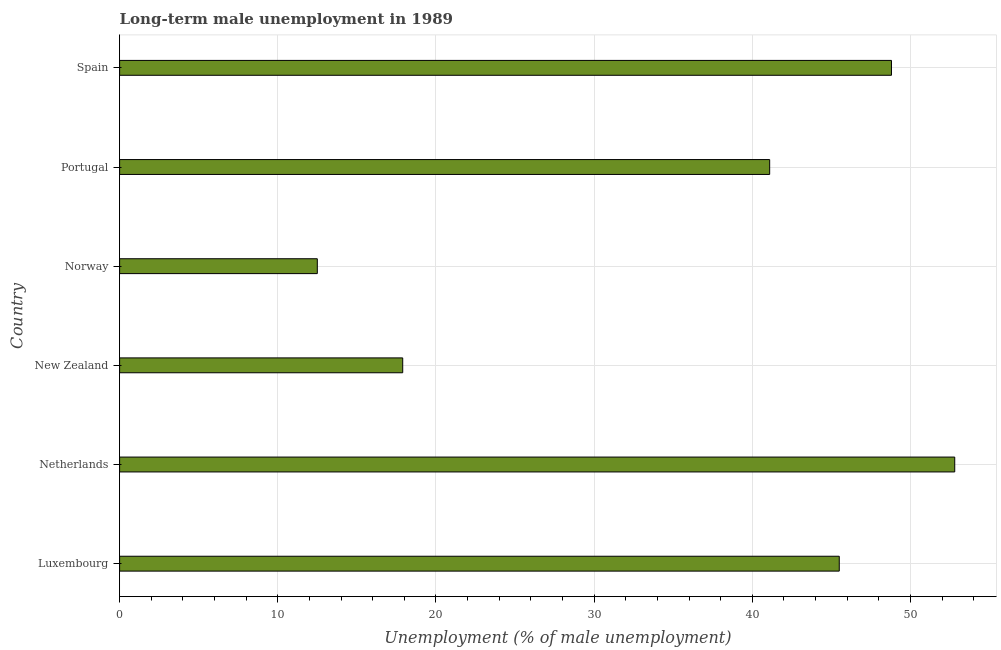Does the graph contain any zero values?
Provide a succinct answer. No. Does the graph contain grids?
Offer a terse response. Yes. What is the title of the graph?
Ensure brevity in your answer.  Long-term male unemployment in 1989. What is the label or title of the X-axis?
Offer a terse response. Unemployment (% of male unemployment). What is the long-term male unemployment in Norway?
Keep it short and to the point. 12.5. Across all countries, what is the maximum long-term male unemployment?
Your answer should be very brief. 52.8. Across all countries, what is the minimum long-term male unemployment?
Your response must be concise. 12.5. In which country was the long-term male unemployment minimum?
Your answer should be very brief. Norway. What is the sum of the long-term male unemployment?
Your answer should be very brief. 218.6. What is the difference between the long-term male unemployment in New Zealand and Portugal?
Your answer should be compact. -23.2. What is the average long-term male unemployment per country?
Your response must be concise. 36.43. What is the median long-term male unemployment?
Provide a short and direct response. 43.3. What is the ratio of the long-term male unemployment in Netherlands to that in Norway?
Your answer should be very brief. 4.22. What is the difference between the highest and the second highest long-term male unemployment?
Provide a short and direct response. 4. Is the sum of the long-term male unemployment in New Zealand and Norway greater than the maximum long-term male unemployment across all countries?
Your answer should be compact. No. What is the difference between the highest and the lowest long-term male unemployment?
Offer a terse response. 40.3. How many bars are there?
Offer a terse response. 6. How many countries are there in the graph?
Your answer should be compact. 6. Are the values on the major ticks of X-axis written in scientific E-notation?
Provide a short and direct response. No. What is the Unemployment (% of male unemployment) of Luxembourg?
Provide a succinct answer. 45.5. What is the Unemployment (% of male unemployment) in Netherlands?
Offer a very short reply. 52.8. What is the Unemployment (% of male unemployment) in New Zealand?
Keep it short and to the point. 17.9. What is the Unemployment (% of male unemployment) in Portugal?
Offer a very short reply. 41.1. What is the Unemployment (% of male unemployment) of Spain?
Offer a terse response. 48.8. What is the difference between the Unemployment (% of male unemployment) in Luxembourg and Netherlands?
Keep it short and to the point. -7.3. What is the difference between the Unemployment (% of male unemployment) in Luxembourg and New Zealand?
Offer a very short reply. 27.6. What is the difference between the Unemployment (% of male unemployment) in Luxembourg and Norway?
Your response must be concise. 33. What is the difference between the Unemployment (% of male unemployment) in Luxembourg and Portugal?
Keep it short and to the point. 4.4. What is the difference between the Unemployment (% of male unemployment) in Netherlands and New Zealand?
Ensure brevity in your answer.  34.9. What is the difference between the Unemployment (% of male unemployment) in Netherlands and Norway?
Offer a terse response. 40.3. What is the difference between the Unemployment (% of male unemployment) in Netherlands and Spain?
Provide a succinct answer. 4. What is the difference between the Unemployment (% of male unemployment) in New Zealand and Portugal?
Keep it short and to the point. -23.2. What is the difference between the Unemployment (% of male unemployment) in New Zealand and Spain?
Provide a succinct answer. -30.9. What is the difference between the Unemployment (% of male unemployment) in Norway and Portugal?
Your answer should be compact. -28.6. What is the difference between the Unemployment (% of male unemployment) in Norway and Spain?
Your answer should be very brief. -36.3. What is the difference between the Unemployment (% of male unemployment) in Portugal and Spain?
Keep it short and to the point. -7.7. What is the ratio of the Unemployment (% of male unemployment) in Luxembourg to that in Netherlands?
Ensure brevity in your answer.  0.86. What is the ratio of the Unemployment (% of male unemployment) in Luxembourg to that in New Zealand?
Keep it short and to the point. 2.54. What is the ratio of the Unemployment (% of male unemployment) in Luxembourg to that in Norway?
Make the answer very short. 3.64. What is the ratio of the Unemployment (% of male unemployment) in Luxembourg to that in Portugal?
Make the answer very short. 1.11. What is the ratio of the Unemployment (% of male unemployment) in Luxembourg to that in Spain?
Your response must be concise. 0.93. What is the ratio of the Unemployment (% of male unemployment) in Netherlands to that in New Zealand?
Offer a very short reply. 2.95. What is the ratio of the Unemployment (% of male unemployment) in Netherlands to that in Norway?
Your answer should be very brief. 4.22. What is the ratio of the Unemployment (% of male unemployment) in Netherlands to that in Portugal?
Your answer should be compact. 1.28. What is the ratio of the Unemployment (% of male unemployment) in Netherlands to that in Spain?
Provide a short and direct response. 1.08. What is the ratio of the Unemployment (% of male unemployment) in New Zealand to that in Norway?
Give a very brief answer. 1.43. What is the ratio of the Unemployment (% of male unemployment) in New Zealand to that in Portugal?
Provide a succinct answer. 0.44. What is the ratio of the Unemployment (% of male unemployment) in New Zealand to that in Spain?
Your answer should be compact. 0.37. What is the ratio of the Unemployment (% of male unemployment) in Norway to that in Portugal?
Offer a very short reply. 0.3. What is the ratio of the Unemployment (% of male unemployment) in Norway to that in Spain?
Your answer should be very brief. 0.26. What is the ratio of the Unemployment (% of male unemployment) in Portugal to that in Spain?
Keep it short and to the point. 0.84. 